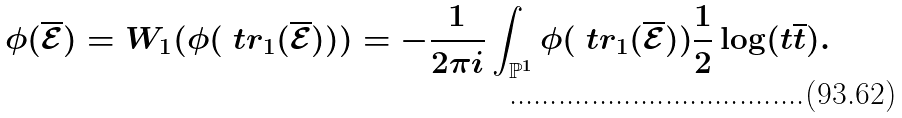Convert formula to latex. <formula><loc_0><loc_0><loc_500><loc_500>\phi ( \overline { \mathcal { E } } ) = W _ { 1 } ( \phi ( \ t r _ { 1 } ( \overline { \mathcal { E } } ) ) ) = - \frac { 1 } { 2 \pi i } \int _ { \mathbb { P } ^ { 1 } } \phi ( \ t r _ { 1 } ( \overline { \mathcal { E } } ) ) \frac { 1 } { 2 } \log ( t \overline { t } ) .</formula> 